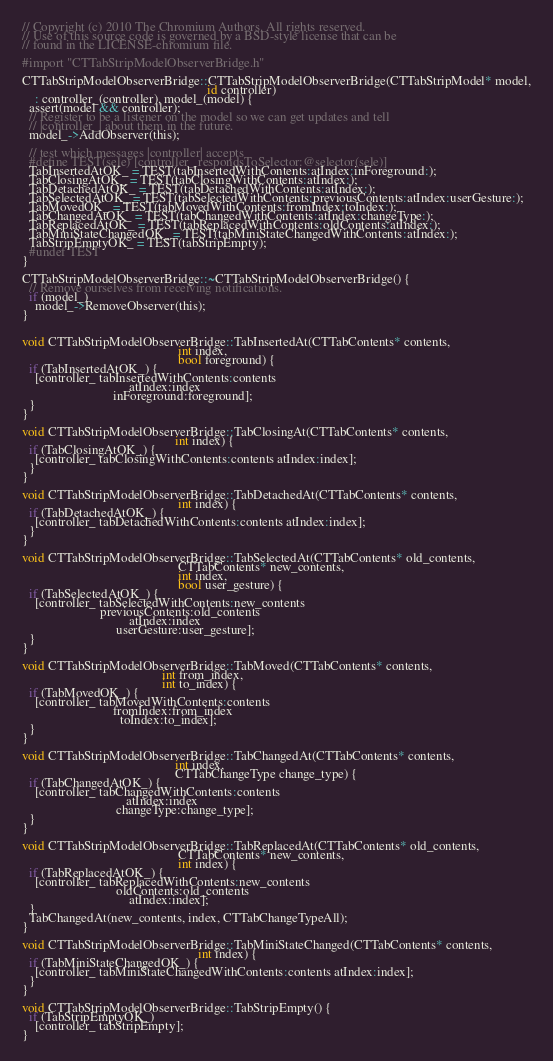<code> <loc_0><loc_0><loc_500><loc_500><_ObjectiveC_>// Copyright (c) 2010 The Chromium Authors. All rights reserved.
// Use of this source code is governed by a BSD-style license that can be
// found in the LICENSE-chromium file.

#import "CTTabStripModelObserverBridge.h"

CTTabStripModelObserverBridge::CTTabStripModelObserverBridge(CTTabStripModel* model,
                                                         id controller)
    : controller_(controller), model_(model) {
  assert(model && controller);
  // Register to be a listener on the model so we can get updates and tell
  // |controller_| about them in the future.
  model_->AddObserver(this);
  
  // test which messages |controller| accepts
  #define TEST(sele) [controller_ respondsToSelector:@selector(sele)]
  TabInsertedAtOK_ = TEST(tabInsertedWithContents:atIndex:inForeground:);
  TabClosingAtOK_ = TEST(tabClosingWithContents:atIndex:);
  TabDetachedAtOK_ = TEST(tabDetachedWithContents:atIndex:);
  TabSelectedAtOK_ = TEST(tabSelectedWithContents:previousContents:atIndex:userGesture:);
  TabMovedOK_ = TEST(tabMovedWithContents:fromIndex:toIndex:);
  TabChangedAtOK_ = TEST(tabChangedWithContents:atIndex:changeType:);
  TabReplacedAtOK_ = TEST(tabReplacedWithContents:oldContents:atIndex:);
  TabMiniStateChangedOK_ = TEST(tabMiniStateChangedWithContents:atIndex:);
  TabStripEmptyOK_ = TEST(tabStripEmpty);
  #undef TEST
}

CTTabStripModelObserverBridge::~CTTabStripModelObserverBridge() {
  // Remove ourselves from receiving notifications.
  if (model_)
    model_->RemoveObserver(this);
}


void CTTabStripModelObserverBridge::TabInsertedAt(CTTabContents* contents,
                                                int index,
                                                bool foreground) {
  if (TabInsertedAtOK_) {
    [controller_ tabInsertedWithContents:contents
                                 atIndex:index
                            inForeground:foreground];
  }
}

void CTTabStripModelObserverBridge::TabClosingAt(CTTabContents* contents,
                                               int index) {
  if (TabClosingAtOK_) {
    [controller_ tabClosingWithContents:contents atIndex:index];
  }
}

void CTTabStripModelObserverBridge::TabDetachedAt(CTTabContents* contents,
                                                int index) {
  if (TabDetachedAtOK_) {
    [controller_ tabDetachedWithContents:contents atIndex:index];
  }
}

void CTTabStripModelObserverBridge::TabSelectedAt(CTTabContents* old_contents,
                                                CTTabContents* new_contents,
                                                int index,
                                                bool user_gesture) {
  if (TabSelectedAtOK_) {
    [controller_ tabSelectedWithContents:new_contents
                        previousContents:old_contents
                                 atIndex:index
                             userGesture:user_gesture];
  }
}

void CTTabStripModelObserverBridge::TabMoved(CTTabContents* contents,
                                           int from_index,
                                           int to_index) {
  if (TabMovedOK_) {
    [controller_ tabMovedWithContents:contents
                            fromIndex:from_index
                              toIndex:to_index];
  }
}

void CTTabStripModelObserverBridge::TabChangedAt(CTTabContents* contents,
                                               int index,
                                               CTTabChangeType change_type) {
  if (TabChangedAtOK_) {
    [controller_ tabChangedWithContents:contents
                                atIndex:index
                             changeType:change_type];
  }
}

void CTTabStripModelObserverBridge::TabReplacedAt(CTTabContents* old_contents,
                                                CTTabContents* new_contents,
                                                int index) {
  if (TabReplacedAtOK_) {
    [controller_ tabReplacedWithContents:new_contents
                             oldContents:old_contents
                                 atIndex:index];
  }
  TabChangedAt(new_contents, index, CTTabChangeTypeAll);
}

void CTTabStripModelObserverBridge::TabMiniStateChanged(CTTabContents* contents,
                                                      int index) {
  if (TabMiniStateChangedOK_) {
    [controller_ tabMiniStateChangedWithContents:contents atIndex:index];
  }
}

void CTTabStripModelObserverBridge::TabStripEmpty() {
  if (TabStripEmptyOK_)
    [controller_ tabStripEmpty];
}
</code> 